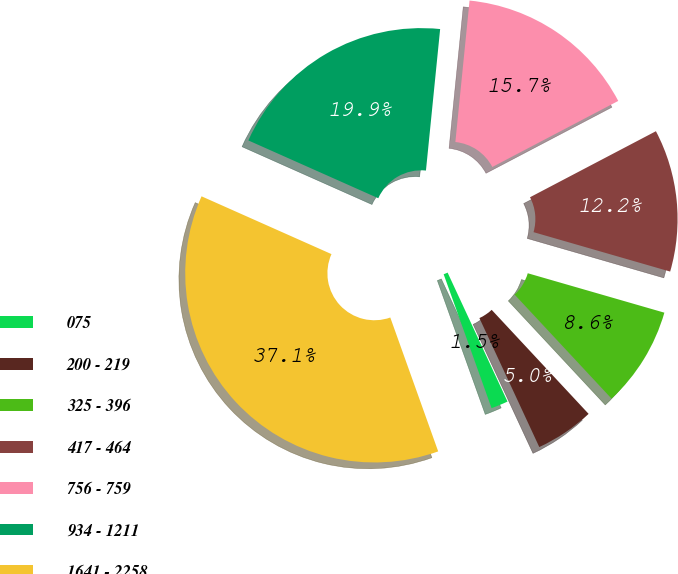<chart> <loc_0><loc_0><loc_500><loc_500><pie_chart><fcel>075<fcel>200 - 219<fcel>325 - 396<fcel>417 - 464<fcel>756 - 759<fcel>934 - 1211<fcel>1641 - 2258<nl><fcel>1.45%<fcel>5.02%<fcel>8.59%<fcel>12.16%<fcel>15.72%<fcel>19.93%<fcel>37.13%<nl></chart> 